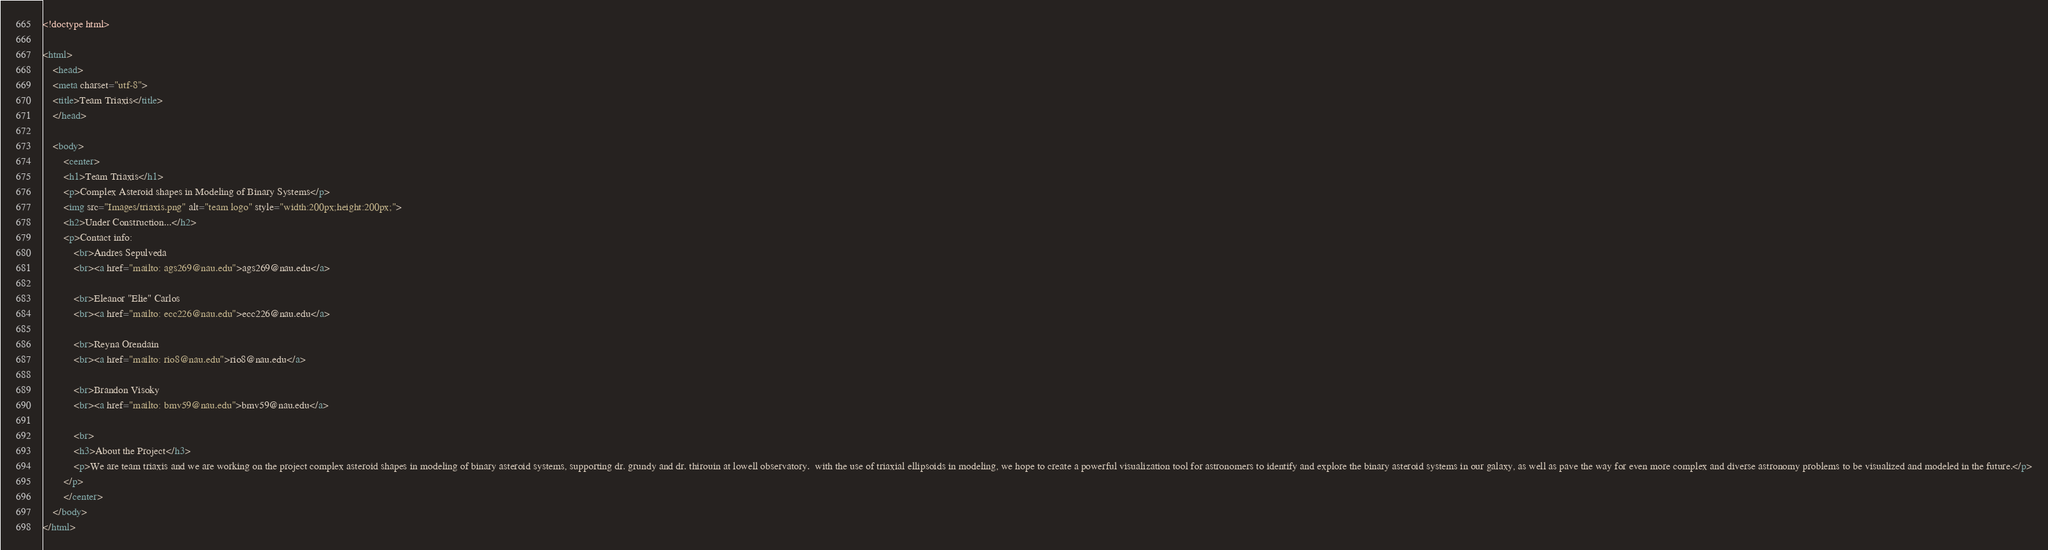Convert code to text. <code><loc_0><loc_0><loc_500><loc_500><_HTML_><!doctype html>

<html>
    <head>
    <meta charset="utf-8">
    <title>Team Triaxis</title>
    </head>

    <body>
        <center>
        <h1>Team Triaxis</h1>
        <p>Complex Asteroid shapes in Modeling of Binary Systems</p>
        <img src="Images/triaxis.png" alt="team logo" style="width:200px;height:200px;">
        <h2>Under Construction...</h2>
        <p>Contact info: 
            <br>Andres Sepulveda
            <br><a href="mailto: ags269@nau.edu">ags269@nau.edu</a>

            <br>Eleanor "Elie" Carlos
            <br><a href="mailto: ecc226@nau.edu">ecc226@nau.edu</a>

            <br>Reyna Orendain
            <br><a href="mailto: rio8@nau.edu">rio8@nau.edu</a>

            <br>Brandon Visoky
            <br><a href="mailto: bmv59@nau.edu">bmv59@nau.edu</a>

            <br>
            <h3>About the Project</h3>
            <p>We are team triaxis and we are working on the project complex asteroid shapes in modeling of binary asteroid systems, supporting dr. grundy and dr. thirouin at lowell observatory.  with the use of triaxial ellipsoids in modeling, we hope to create a powerful visualization tool for astronomers to identify and explore the binary asteroid systems in our galaxy, as well as pave the way for even more complex and diverse astronomy problems to be visualized and modeled in the future.</p>
        </p>
        </center>
    </body>
</html>
</code> 